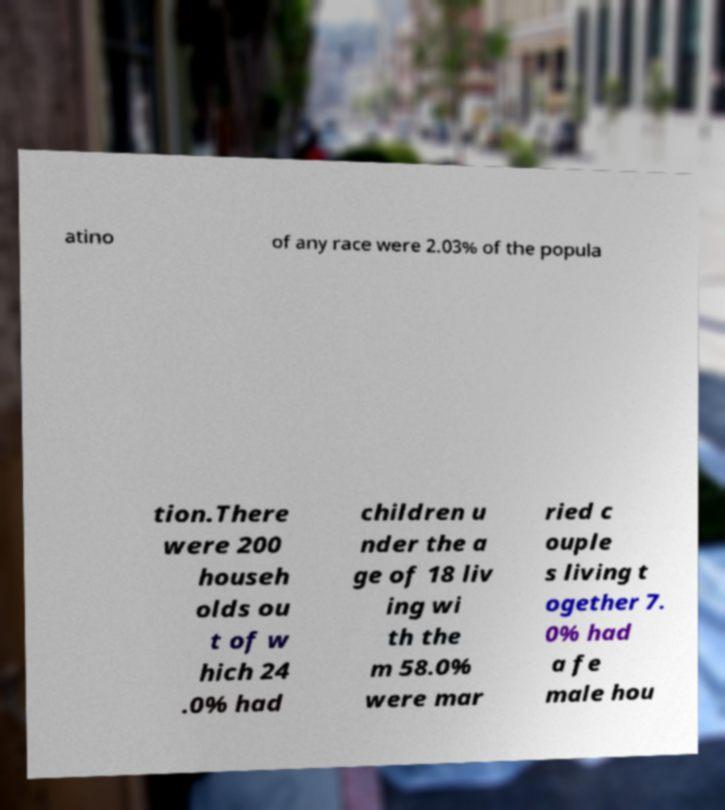Please read and relay the text visible in this image. What does it say? atino of any race were 2.03% of the popula tion.There were 200 househ olds ou t of w hich 24 .0% had children u nder the a ge of 18 liv ing wi th the m 58.0% were mar ried c ouple s living t ogether 7. 0% had a fe male hou 